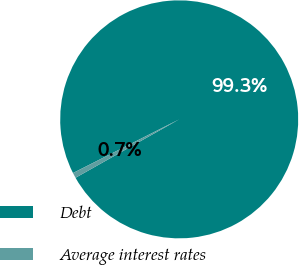Convert chart to OTSL. <chart><loc_0><loc_0><loc_500><loc_500><pie_chart><fcel>Debt<fcel>Average interest rates<nl><fcel>99.28%<fcel>0.72%<nl></chart> 